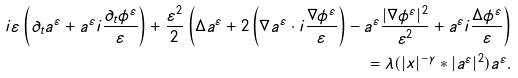Convert formula to latex. <formula><loc_0><loc_0><loc_500><loc_500>i \varepsilon \left ( \partial _ { t } a ^ { \varepsilon } + a ^ { \varepsilon } i \frac { \partial _ { t } \phi ^ { \varepsilon } } { \varepsilon } \right ) + \frac { \varepsilon ^ { 2 } } { 2 } \left ( \Delta a ^ { \varepsilon } + 2 \left ( \nabla a ^ { \varepsilon } \cdot i \frac { \nabla \phi ^ { \varepsilon } } { \varepsilon } \right ) - a ^ { \varepsilon } \frac { | \nabla \phi ^ { \varepsilon } | ^ { 2 } } { \varepsilon ^ { 2 } } + a ^ { \varepsilon } i \frac { \Delta \phi ^ { \varepsilon } } { \varepsilon } \right ) \\ = \lambda ( | x | ^ { - \gamma } * | a ^ { \varepsilon } | ^ { 2 } ) a ^ { \varepsilon } .</formula> 